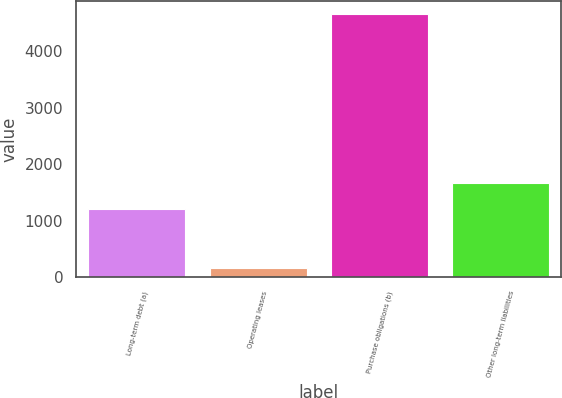<chart> <loc_0><loc_0><loc_500><loc_500><bar_chart><fcel>Long-term debt (a)<fcel>Operating leases<fcel>Purchase obligations (b)<fcel>Other long-term liabilities<nl><fcel>1213<fcel>167<fcel>4653<fcel>1661.6<nl></chart> 